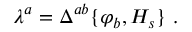<formula> <loc_0><loc_0><loc_500><loc_500>\lambda ^ { a } = \Delta ^ { a b } \{ \varphi _ { b } , H _ { s } \} \ .</formula> 